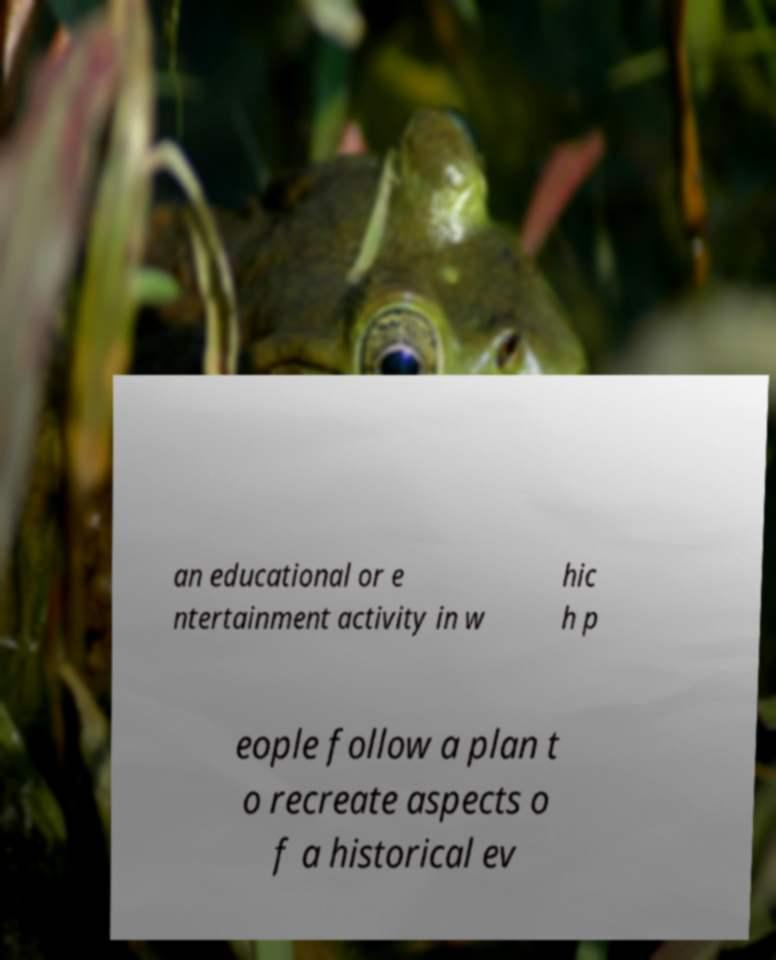Could you extract and type out the text from this image? an educational or e ntertainment activity in w hic h p eople follow a plan t o recreate aspects o f a historical ev 